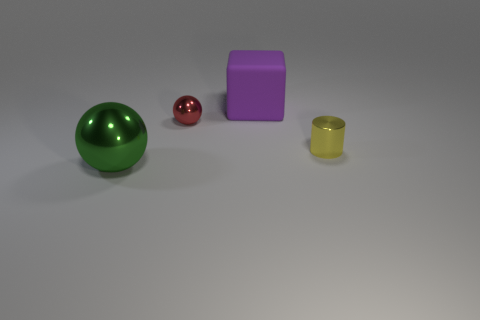The shiny thing that is to the right of the large thing right of the object in front of the cylinder is what shape?
Make the answer very short. Cylinder. How many objects are yellow cylinders or small green metal things?
Provide a succinct answer. 1. There is a shiny object that is to the right of the big block; does it have the same shape as the big object in front of the purple thing?
Provide a short and direct response. No. How many tiny things are both right of the tiny ball and left of the large purple matte object?
Your answer should be very brief. 0. How many other things are the same size as the green shiny thing?
Offer a terse response. 1. There is a thing that is left of the matte cube and in front of the tiny metal sphere; what is its material?
Your answer should be compact. Metal. There is a tiny cylinder; does it have the same color as the metallic ball that is to the right of the big ball?
Give a very brief answer. No. There is another metal thing that is the same shape as the green shiny thing; what is its size?
Offer a very short reply. Small. There is a thing that is right of the red ball and in front of the matte thing; what is its shape?
Make the answer very short. Cylinder. Do the purple object and the sphere that is behind the green object have the same size?
Give a very brief answer. No. 